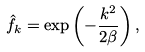Convert formula to latex. <formula><loc_0><loc_0><loc_500><loc_500>\hat { f } _ { k } = \exp \left ( - \frac { k ^ { 2 } } { 2 \beta } \right ) ,</formula> 